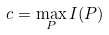Convert formula to latex. <formula><loc_0><loc_0><loc_500><loc_500>c = \max _ { P } I ( P )</formula> 